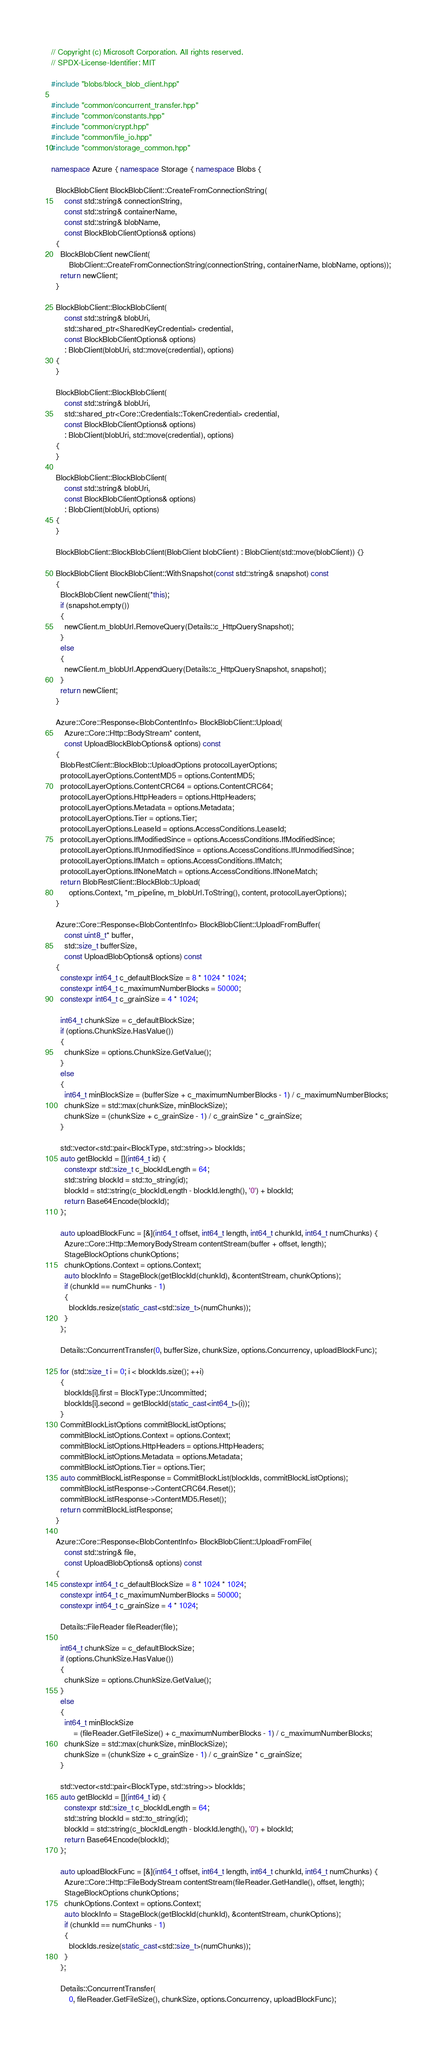Convert code to text. <code><loc_0><loc_0><loc_500><loc_500><_C++_>// Copyright (c) Microsoft Corporation. All rights reserved.
// SPDX-License-Identifier: MIT

#include "blobs/block_blob_client.hpp"

#include "common/concurrent_transfer.hpp"
#include "common/constants.hpp"
#include "common/crypt.hpp"
#include "common/file_io.hpp"
#include "common/storage_common.hpp"

namespace Azure { namespace Storage { namespace Blobs {

  BlockBlobClient BlockBlobClient::CreateFromConnectionString(
      const std::string& connectionString,
      const std::string& containerName,
      const std::string& blobName,
      const BlockBlobClientOptions& options)
  {
    BlockBlobClient newClient(
        BlobClient::CreateFromConnectionString(connectionString, containerName, blobName, options));
    return newClient;
  }

  BlockBlobClient::BlockBlobClient(
      const std::string& blobUri,
      std::shared_ptr<SharedKeyCredential> credential,
      const BlockBlobClientOptions& options)
      : BlobClient(blobUri, std::move(credential), options)
  {
  }

  BlockBlobClient::BlockBlobClient(
      const std::string& blobUri,
      std::shared_ptr<Core::Credentials::TokenCredential> credential,
      const BlockBlobClientOptions& options)
      : BlobClient(blobUri, std::move(credential), options)
  {
  }

  BlockBlobClient::BlockBlobClient(
      const std::string& blobUri,
      const BlockBlobClientOptions& options)
      : BlobClient(blobUri, options)
  {
  }

  BlockBlobClient::BlockBlobClient(BlobClient blobClient) : BlobClient(std::move(blobClient)) {}

  BlockBlobClient BlockBlobClient::WithSnapshot(const std::string& snapshot) const
  {
    BlockBlobClient newClient(*this);
    if (snapshot.empty())
    {
      newClient.m_blobUrl.RemoveQuery(Details::c_HttpQuerySnapshot);
    }
    else
    {
      newClient.m_blobUrl.AppendQuery(Details::c_HttpQuerySnapshot, snapshot);
    }
    return newClient;
  }

  Azure::Core::Response<BlobContentInfo> BlockBlobClient::Upload(
      Azure::Core::Http::BodyStream* content,
      const UploadBlockBlobOptions& options) const
  {
    BlobRestClient::BlockBlob::UploadOptions protocolLayerOptions;
    protocolLayerOptions.ContentMD5 = options.ContentMD5;
    protocolLayerOptions.ContentCRC64 = options.ContentCRC64;
    protocolLayerOptions.HttpHeaders = options.HttpHeaders;
    protocolLayerOptions.Metadata = options.Metadata;
    protocolLayerOptions.Tier = options.Tier;
    protocolLayerOptions.LeaseId = options.AccessConditions.LeaseId;
    protocolLayerOptions.IfModifiedSince = options.AccessConditions.IfModifiedSince;
    protocolLayerOptions.IfUnmodifiedSince = options.AccessConditions.IfUnmodifiedSince;
    protocolLayerOptions.IfMatch = options.AccessConditions.IfMatch;
    protocolLayerOptions.IfNoneMatch = options.AccessConditions.IfNoneMatch;
    return BlobRestClient::BlockBlob::Upload(
        options.Context, *m_pipeline, m_blobUrl.ToString(), content, protocolLayerOptions);
  }

  Azure::Core::Response<BlobContentInfo> BlockBlobClient::UploadFromBuffer(
      const uint8_t* buffer,
      std::size_t bufferSize,
      const UploadBlobOptions& options) const
  {
    constexpr int64_t c_defaultBlockSize = 8 * 1024 * 1024;
    constexpr int64_t c_maximumNumberBlocks = 50000;
    constexpr int64_t c_grainSize = 4 * 1024;

    int64_t chunkSize = c_defaultBlockSize;
    if (options.ChunkSize.HasValue())
    {
      chunkSize = options.ChunkSize.GetValue();
    }
    else
    {
      int64_t minBlockSize = (bufferSize + c_maximumNumberBlocks - 1) / c_maximumNumberBlocks;
      chunkSize = std::max(chunkSize, minBlockSize);
      chunkSize = (chunkSize + c_grainSize - 1) / c_grainSize * c_grainSize;
    }

    std::vector<std::pair<BlockType, std::string>> blockIds;
    auto getBlockId = [](int64_t id) {
      constexpr std::size_t c_blockIdLength = 64;
      std::string blockId = std::to_string(id);
      blockId = std::string(c_blockIdLength - blockId.length(), '0') + blockId;
      return Base64Encode(blockId);
    };

    auto uploadBlockFunc = [&](int64_t offset, int64_t length, int64_t chunkId, int64_t numChunks) {
      Azure::Core::Http::MemoryBodyStream contentStream(buffer + offset, length);
      StageBlockOptions chunkOptions;
      chunkOptions.Context = options.Context;
      auto blockInfo = StageBlock(getBlockId(chunkId), &contentStream, chunkOptions);
      if (chunkId == numChunks - 1)
      {
        blockIds.resize(static_cast<std::size_t>(numChunks));
      }
    };

    Details::ConcurrentTransfer(0, bufferSize, chunkSize, options.Concurrency, uploadBlockFunc);

    for (std::size_t i = 0; i < blockIds.size(); ++i)
    {
      blockIds[i].first = BlockType::Uncommitted;
      blockIds[i].second = getBlockId(static_cast<int64_t>(i));
    }
    CommitBlockListOptions commitBlockListOptions;
    commitBlockListOptions.Context = options.Context;
    commitBlockListOptions.HttpHeaders = options.HttpHeaders;
    commitBlockListOptions.Metadata = options.Metadata;
    commitBlockListOptions.Tier = options.Tier;
    auto commitBlockListResponse = CommitBlockList(blockIds, commitBlockListOptions);
    commitBlockListResponse->ContentCRC64.Reset();
    commitBlockListResponse->ContentMD5.Reset();
    return commitBlockListResponse;
  }

  Azure::Core::Response<BlobContentInfo> BlockBlobClient::UploadFromFile(
      const std::string& file,
      const UploadBlobOptions& options) const
  {
    constexpr int64_t c_defaultBlockSize = 8 * 1024 * 1024;
    constexpr int64_t c_maximumNumberBlocks = 50000;
    constexpr int64_t c_grainSize = 4 * 1024;

    Details::FileReader fileReader(file);

    int64_t chunkSize = c_defaultBlockSize;
    if (options.ChunkSize.HasValue())
    {
      chunkSize = options.ChunkSize.GetValue();
    }
    else
    {
      int64_t minBlockSize
          = (fileReader.GetFileSize() + c_maximumNumberBlocks - 1) / c_maximumNumberBlocks;
      chunkSize = std::max(chunkSize, minBlockSize);
      chunkSize = (chunkSize + c_grainSize - 1) / c_grainSize * c_grainSize;
    }

    std::vector<std::pair<BlockType, std::string>> blockIds;
    auto getBlockId = [](int64_t id) {
      constexpr std::size_t c_blockIdLength = 64;
      std::string blockId = std::to_string(id);
      blockId = std::string(c_blockIdLength - blockId.length(), '0') + blockId;
      return Base64Encode(blockId);
    };

    auto uploadBlockFunc = [&](int64_t offset, int64_t length, int64_t chunkId, int64_t numChunks) {
      Azure::Core::Http::FileBodyStream contentStream(fileReader.GetHandle(), offset, length);
      StageBlockOptions chunkOptions;
      chunkOptions.Context = options.Context;
      auto blockInfo = StageBlock(getBlockId(chunkId), &contentStream, chunkOptions);
      if (chunkId == numChunks - 1)
      {
        blockIds.resize(static_cast<std::size_t>(numChunks));
      }
    };

    Details::ConcurrentTransfer(
        0, fileReader.GetFileSize(), chunkSize, options.Concurrency, uploadBlockFunc);
</code> 